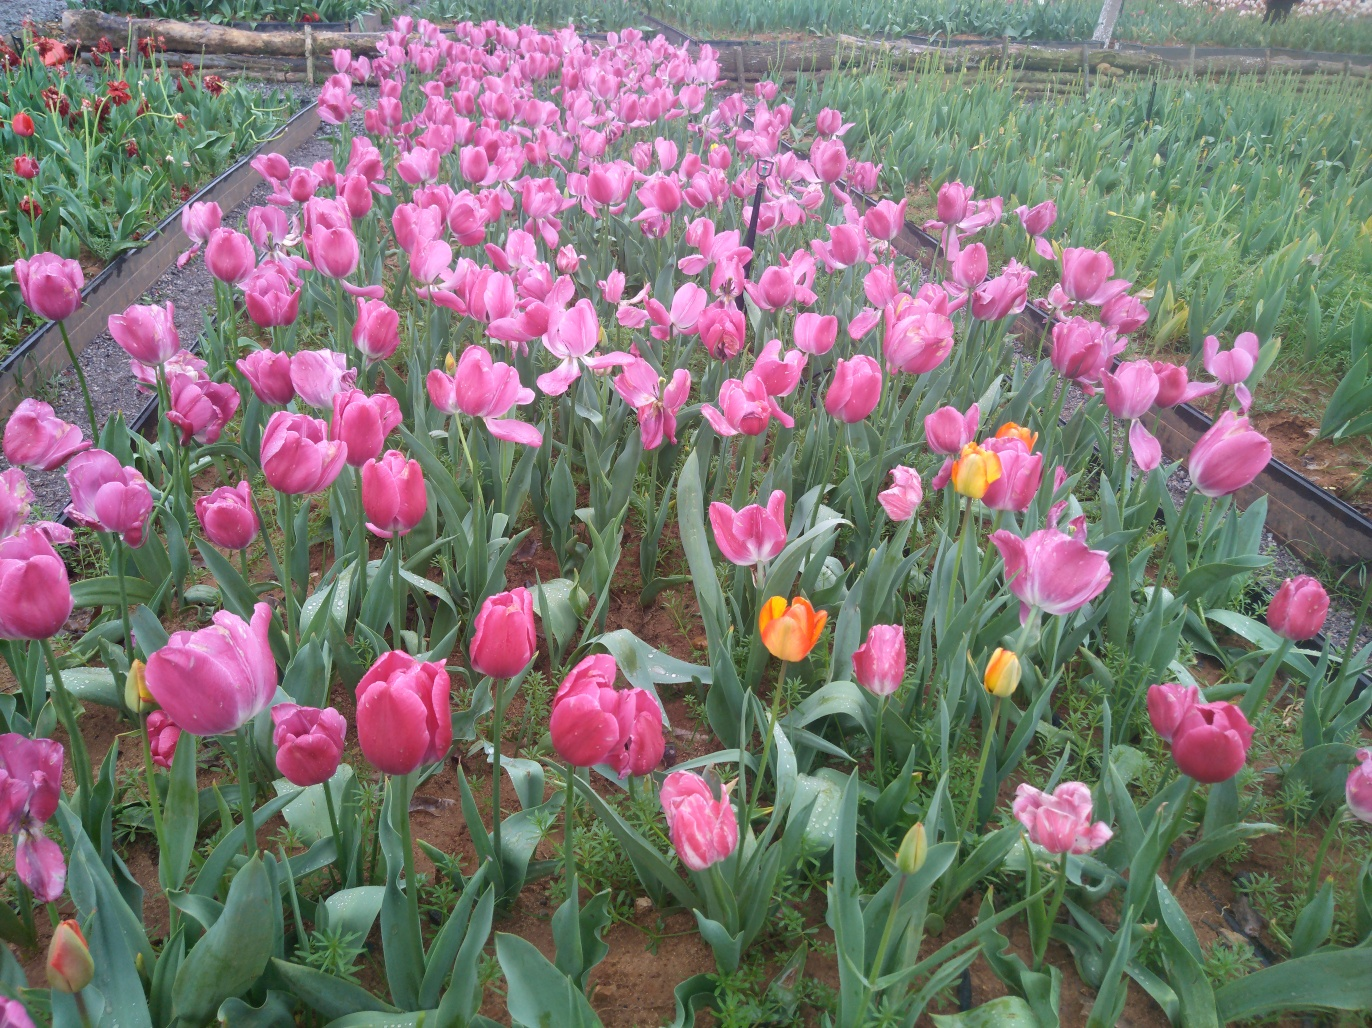What does the image show in terms of flower texture? A. Average texture B. Perfect texture C. No texture D. Great texture Answer with the option's letter from the given choices directly. The flowers in the image can be best described as having a 'great texture' (Option D), which typically denotes a rich, detailed surface quality that is pleasant to look at. The petals of the tulips appear healthy and well-defined, with a smooth and vibrant surface that reflects their natural beauty and careful cultivation. 